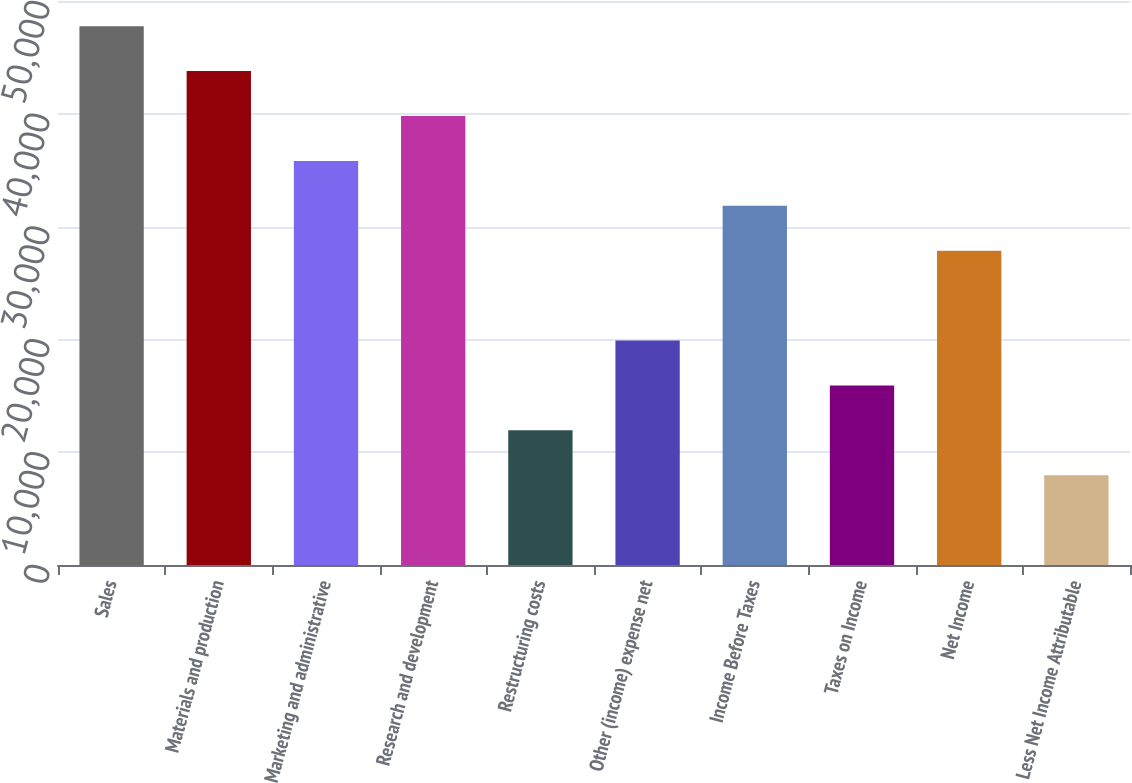Convert chart to OTSL. <chart><loc_0><loc_0><loc_500><loc_500><bar_chart><fcel>Sales<fcel>Materials and production<fcel>Marketing and administrative<fcel>Research and development<fcel>Restructuring costs<fcel>Other (income) expense net<fcel>Income Before Taxes<fcel>Taxes on Income<fcel>Net Income<fcel>Less Net Income Attributable<nl><fcel>47768.1<fcel>43787.6<fcel>35826.4<fcel>39807<fcel>11943.1<fcel>19904.2<fcel>31845.9<fcel>15923.6<fcel>27865.3<fcel>7962.53<nl></chart> 